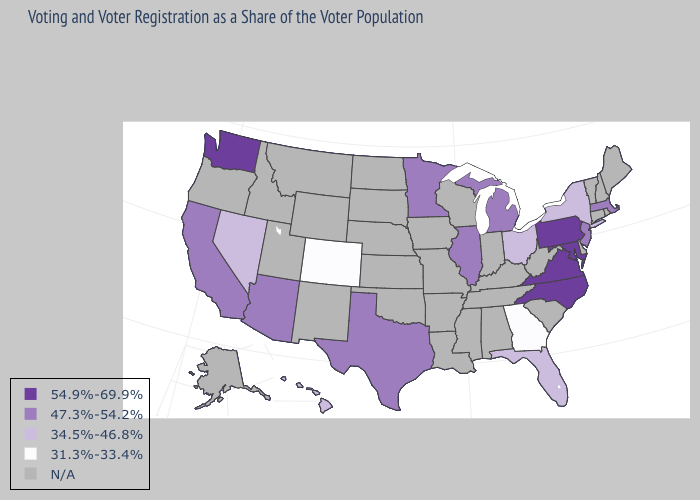What is the value of Massachusetts?
Write a very short answer. 47.3%-54.2%. Does the map have missing data?
Quick response, please. Yes. Name the states that have a value in the range 47.3%-54.2%?
Answer briefly. Arizona, California, Illinois, Massachusetts, Michigan, Minnesota, New Jersey, Texas. What is the highest value in the USA?
Give a very brief answer. 54.9%-69.9%. Does the first symbol in the legend represent the smallest category?
Be succinct. No. Which states have the lowest value in the West?
Answer briefly. Colorado. Which states have the lowest value in the USA?
Short answer required. Colorado, Georgia. Does Minnesota have the lowest value in the MidWest?
Short answer required. No. What is the lowest value in states that border Oklahoma?
Concise answer only. 31.3%-33.4%. Name the states that have a value in the range 54.9%-69.9%?
Be succinct. Maryland, North Carolina, Pennsylvania, Virginia, Washington. What is the value of New York?
Give a very brief answer. 34.5%-46.8%. Does Florida have the lowest value in the USA?
Give a very brief answer. No. 